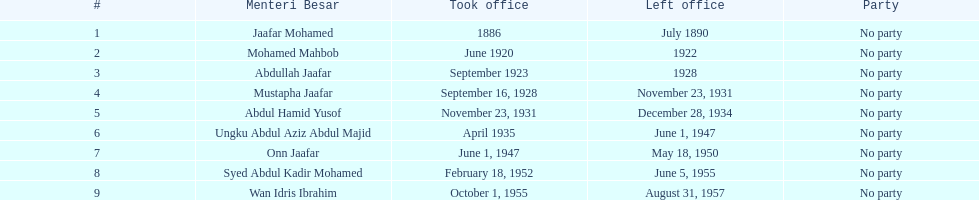What is the number of menteri besar that served 4 or more years? 3. 